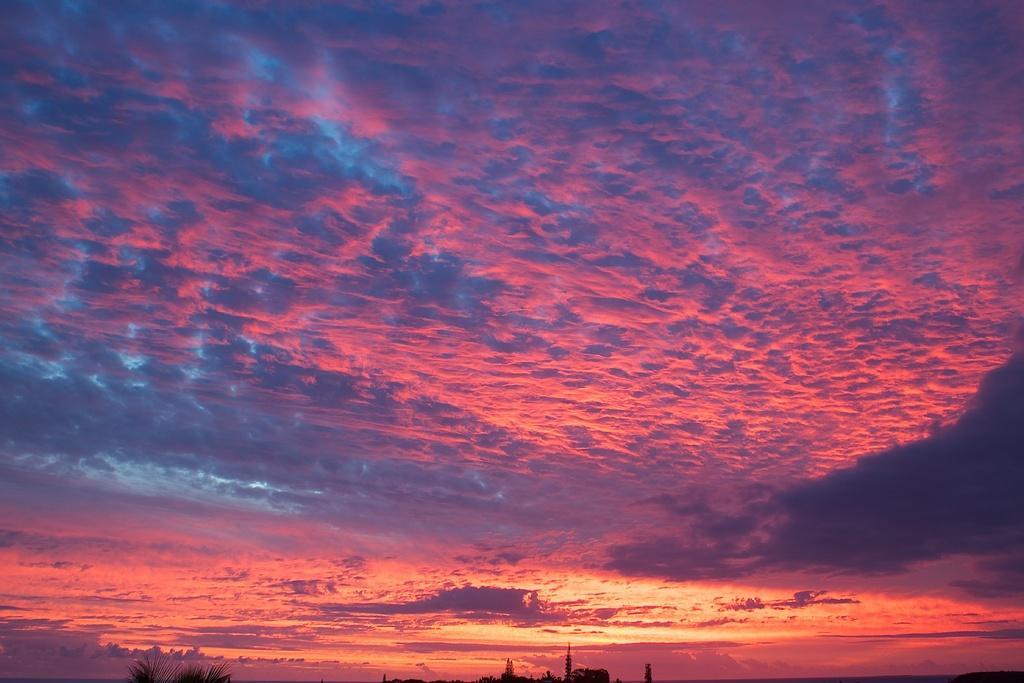Describe this image in one or two sentences. In this picture we can see there are trees and the cloudy sky. 